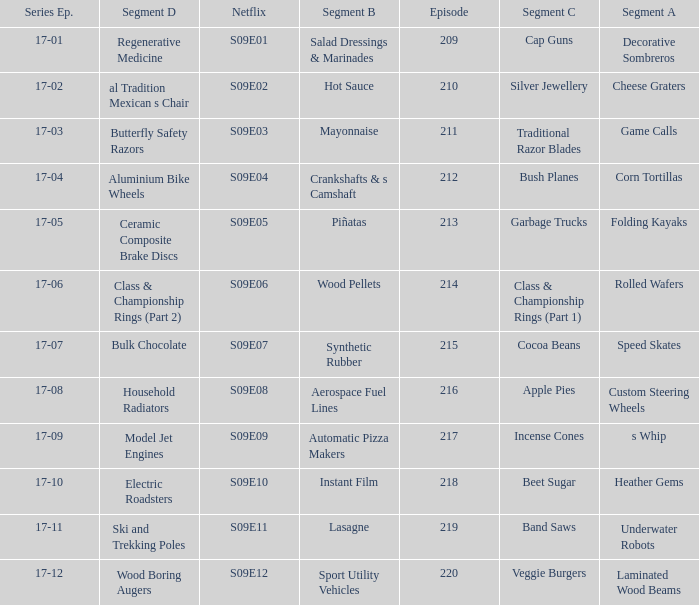Parse the full table. {'header': ['Series Ep.', 'Segment D', 'Netflix', 'Segment B', 'Episode', 'Segment C', 'Segment A'], 'rows': [['17-01', 'Regenerative Medicine', 'S09E01', 'Salad Dressings & Marinades', '209', 'Cap Guns', 'Decorative Sombreros'], ['17-02', 'al Tradition Mexican s Chair', 'S09E02', 'Hot Sauce', '210', 'Silver Jewellery', 'Cheese Graters'], ['17-03', 'Butterfly Safety Razors', 'S09E03', 'Mayonnaise', '211', 'Traditional Razor Blades', 'Game Calls'], ['17-04', 'Aluminium Bike Wheels', 'S09E04', 'Crankshafts & s Camshaft', '212', 'Bush Planes', 'Corn Tortillas'], ['17-05', 'Ceramic Composite Brake Discs', 'S09E05', 'Piñatas', '213', 'Garbage Trucks', 'Folding Kayaks'], ['17-06', 'Class & Championship Rings (Part 2)', 'S09E06', 'Wood Pellets', '214', 'Class & Championship Rings (Part 1)', 'Rolled Wafers'], ['17-07', 'Bulk Chocolate', 'S09E07', 'Synthetic Rubber', '215', 'Cocoa Beans', 'Speed Skates'], ['17-08', 'Household Radiators', 'S09E08', 'Aerospace Fuel Lines', '216', 'Apple Pies', 'Custom Steering Wheels'], ['17-09', 'Model Jet Engines', 'S09E09', 'Automatic Pizza Makers', '217', 'Incense Cones', 's Whip'], ['17-10', 'Electric Roadsters', 'S09E10', 'Instant Film', '218', 'Beet Sugar', 'Heather Gems'], ['17-11', 'Ski and Trekking Poles', 'S09E11', 'Lasagne', '219', 'Band Saws', 'Underwater Robots'], ['17-12', 'Wood Boring Augers', 'S09E12', 'Sport Utility Vehicles', '220', 'Veggie Burgers', 'Laminated Wood Beams']]} Are rolled wafers in many episodes 17-06. 